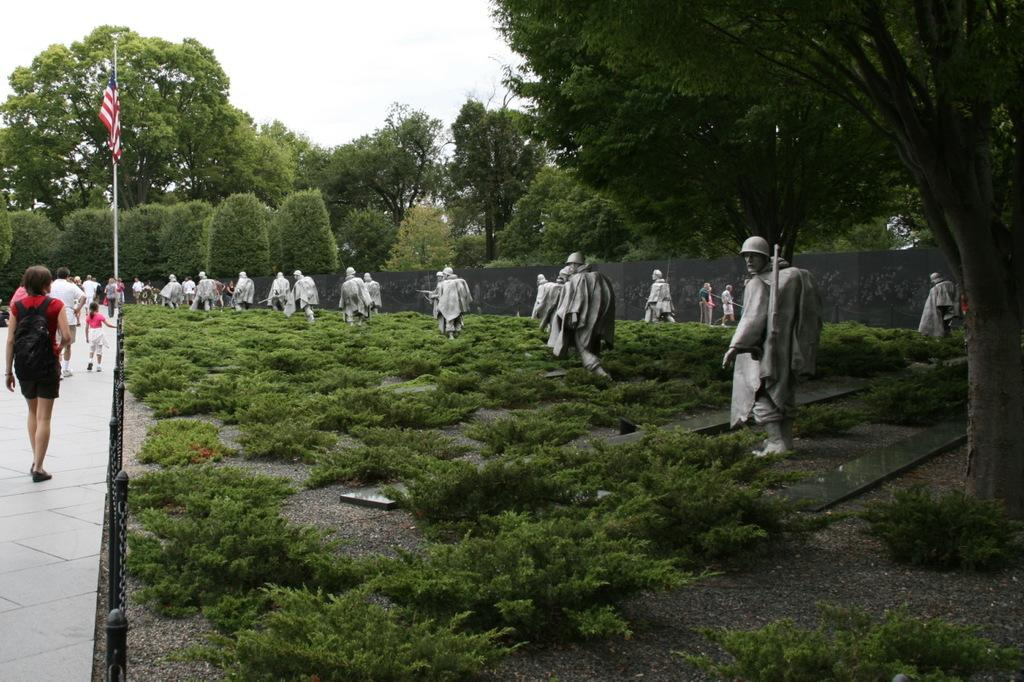What type of objects can be seen in the image? There are statues, plants, trees, and a flag in the image. What else is present in the image? There is a group of people walking and metal rods in the image. Can you describe the vegetation in the image? The image contains plants and trees. What might the metal rods be used for? The metal rods could be used for support or as part of a structure. What time of day is represented by the hour in the image? There is no hour present in the image, as it features statues, plants, trees, a group of people walking, metal rods, and a flag. What type of throne can be seen in the image? There is no throne present in the image. 